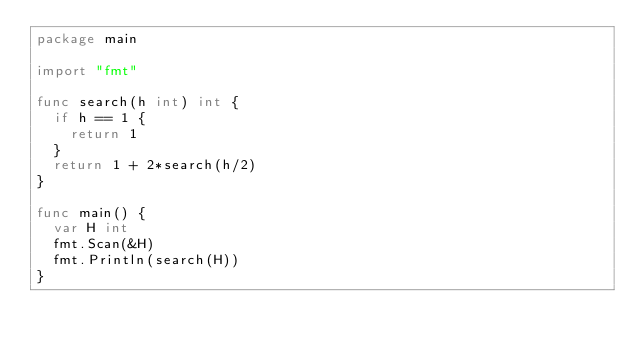Convert code to text. <code><loc_0><loc_0><loc_500><loc_500><_Go_>package main

import "fmt"

func search(h int) int {
	if h == 1 {
		return 1
	}
	return 1 + 2*search(h/2)
}

func main() {
	var H int
	fmt.Scan(&H)
	fmt.Println(search(H))
}
</code> 